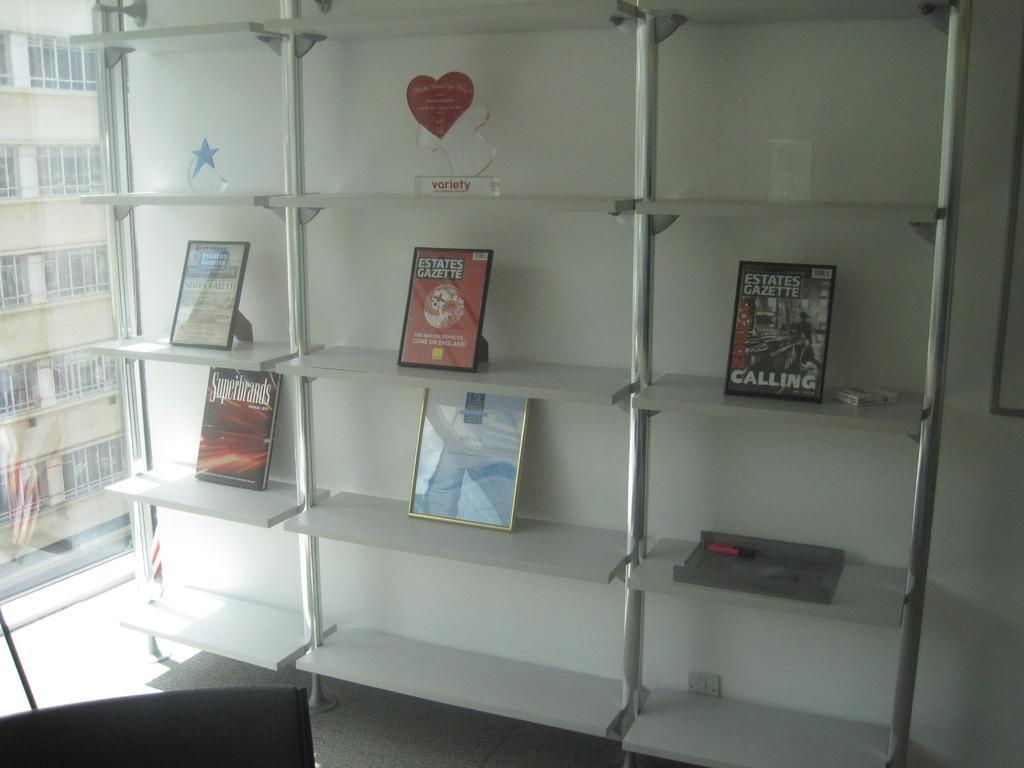How would you summarize this image in a sentence or two? In this image we can see a rack with few picture frames, a tray and few objects looks like trophy and a wall in the background on the left side we can see a building through the glass and there is a black color object in front of the rack. 